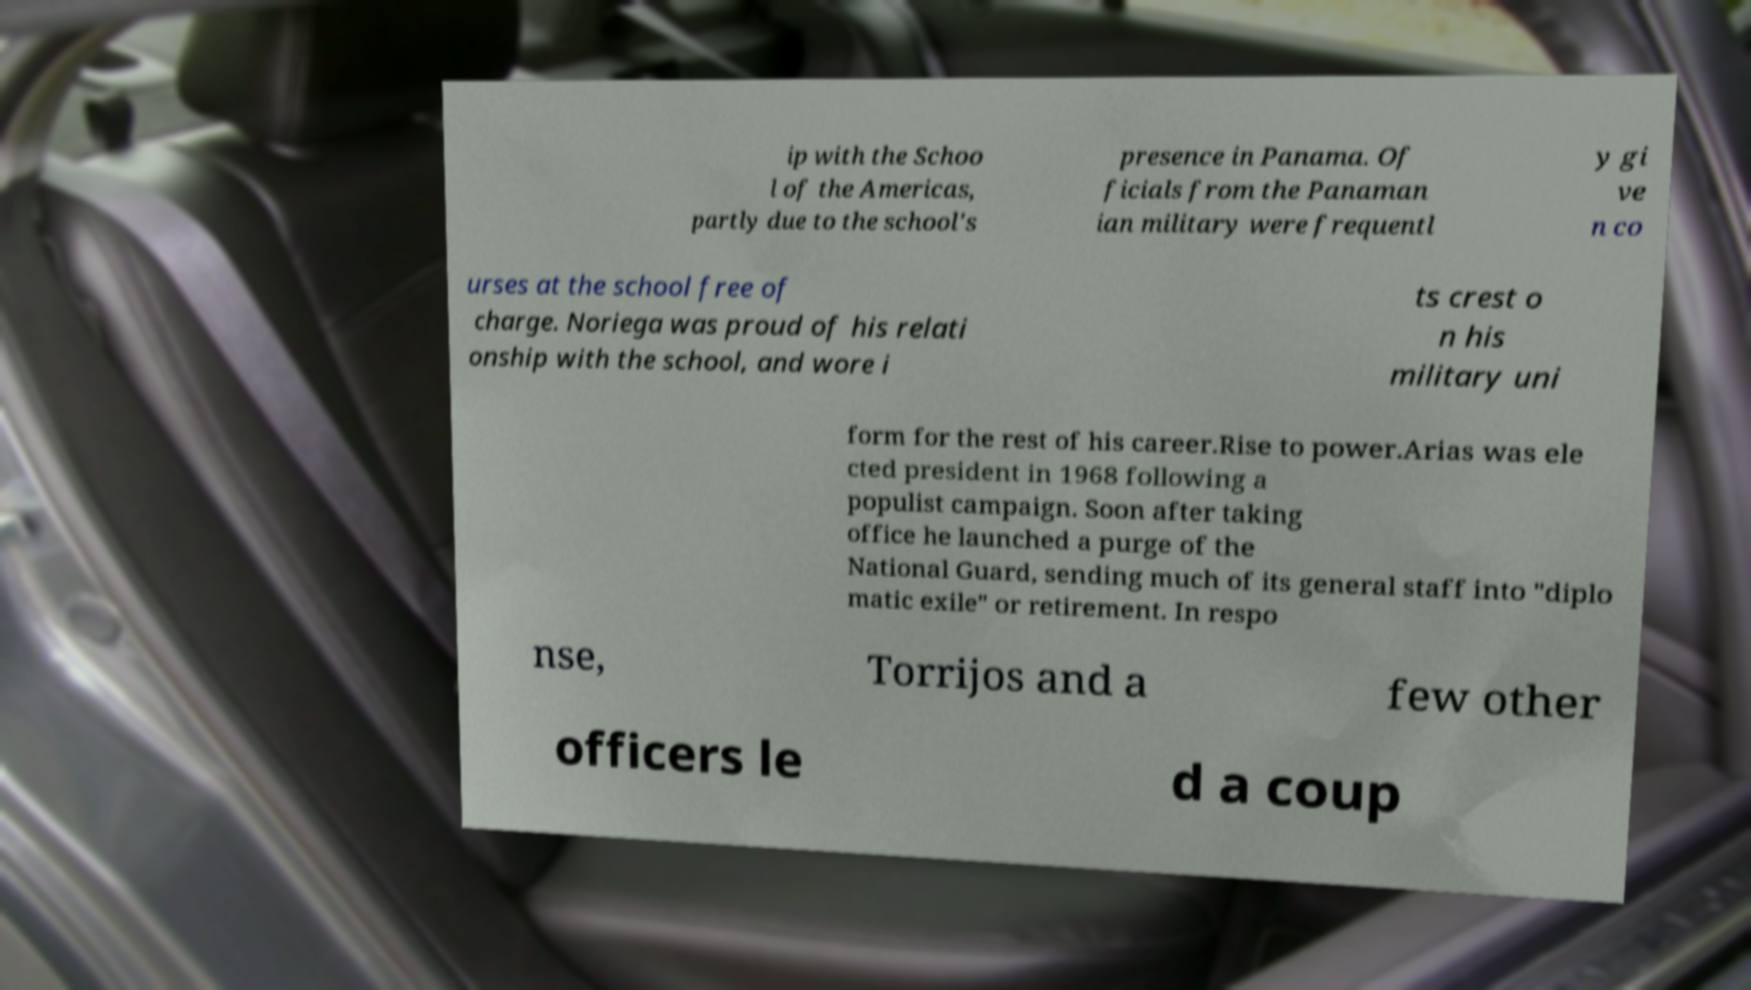There's text embedded in this image that I need extracted. Can you transcribe it verbatim? ip with the Schoo l of the Americas, partly due to the school's presence in Panama. Of ficials from the Panaman ian military were frequentl y gi ve n co urses at the school free of charge. Noriega was proud of his relati onship with the school, and wore i ts crest o n his military uni form for the rest of his career.Rise to power.Arias was ele cted president in 1968 following a populist campaign. Soon after taking office he launched a purge of the National Guard, sending much of its general staff into "diplo matic exile" or retirement. In respo nse, Torrijos and a few other officers le d a coup 